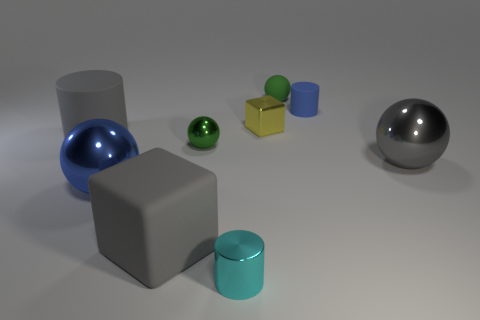Add 1 large yellow matte blocks. How many objects exist? 10 Subtract all spheres. How many objects are left? 5 Subtract 0 brown blocks. How many objects are left? 9 Subtract all blue shiny spheres. Subtract all blue matte cylinders. How many objects are left? 7 Add 5 small rubber cylinders. How many small rubber cylinders are left? 6 Add 1 tiny brown rubber balls. How many tiny brown rubber balls exist? 1 